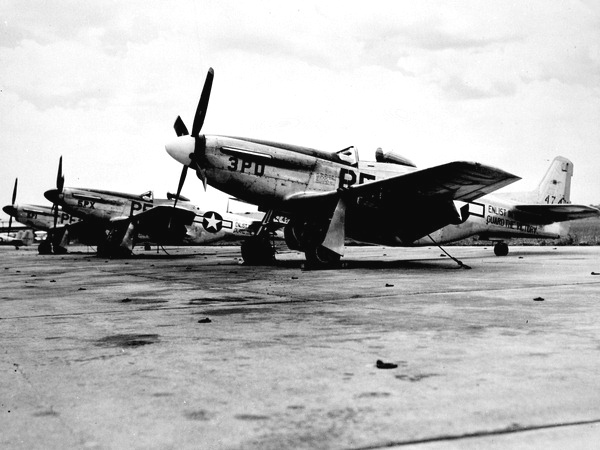How many towers have clocks on them? 0 